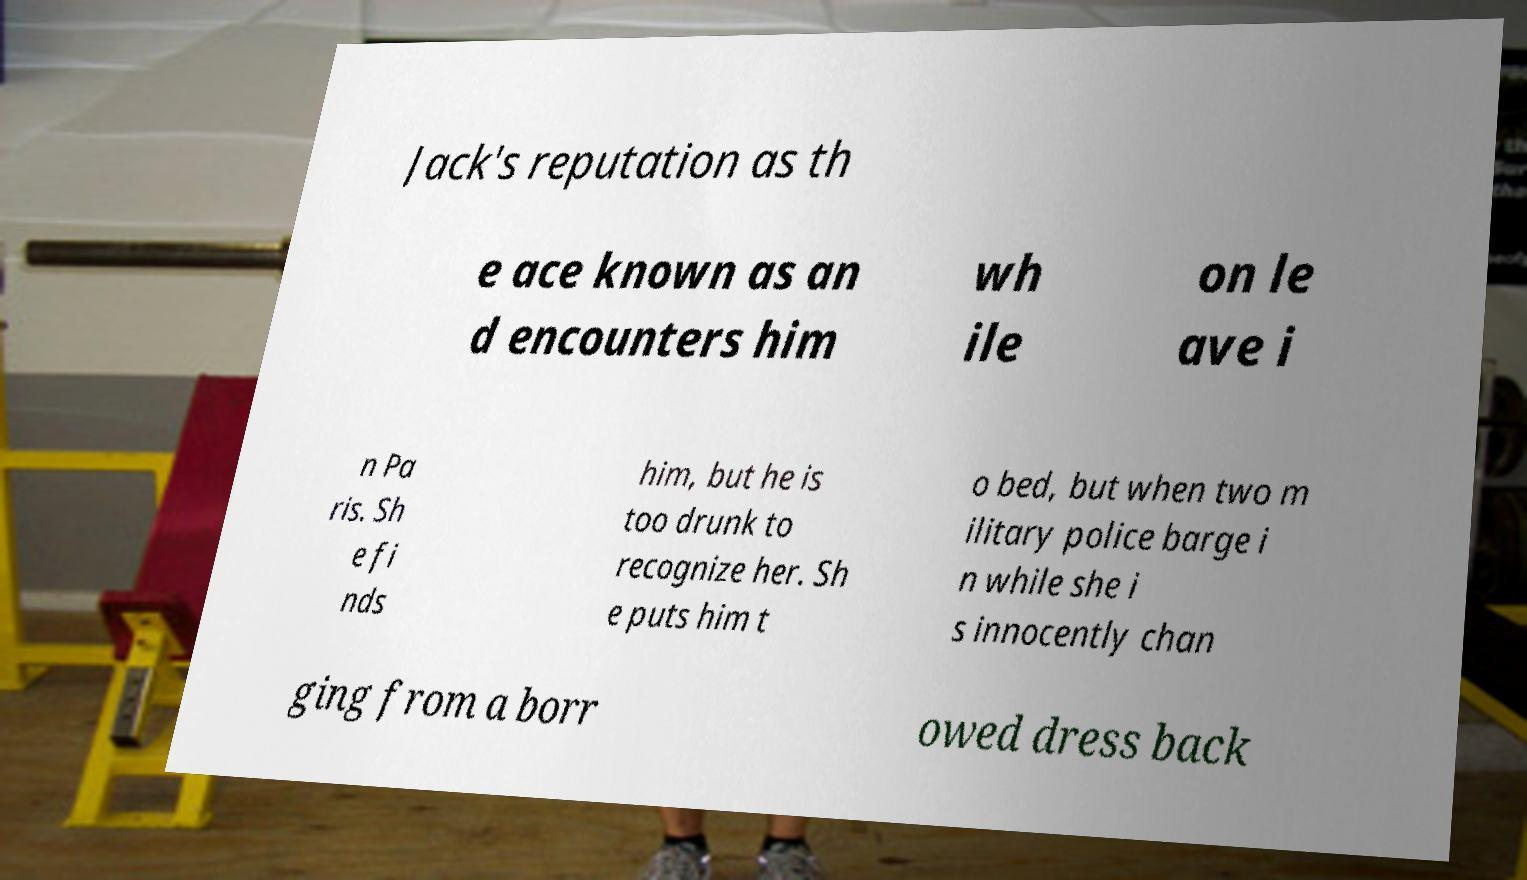There's text embedded in this image that I need extracted. Can you transcribe it verbatim? Jack's reputation as th e ace known as an d encounters him wh ile on le ave i n Pa ris. Sh e fi nds him, but he is too drunk to recognize her. Sh e puts him t o bed, but when two m ilitary police barge i n while she i s innocently chan ging from a borr owed dress back 